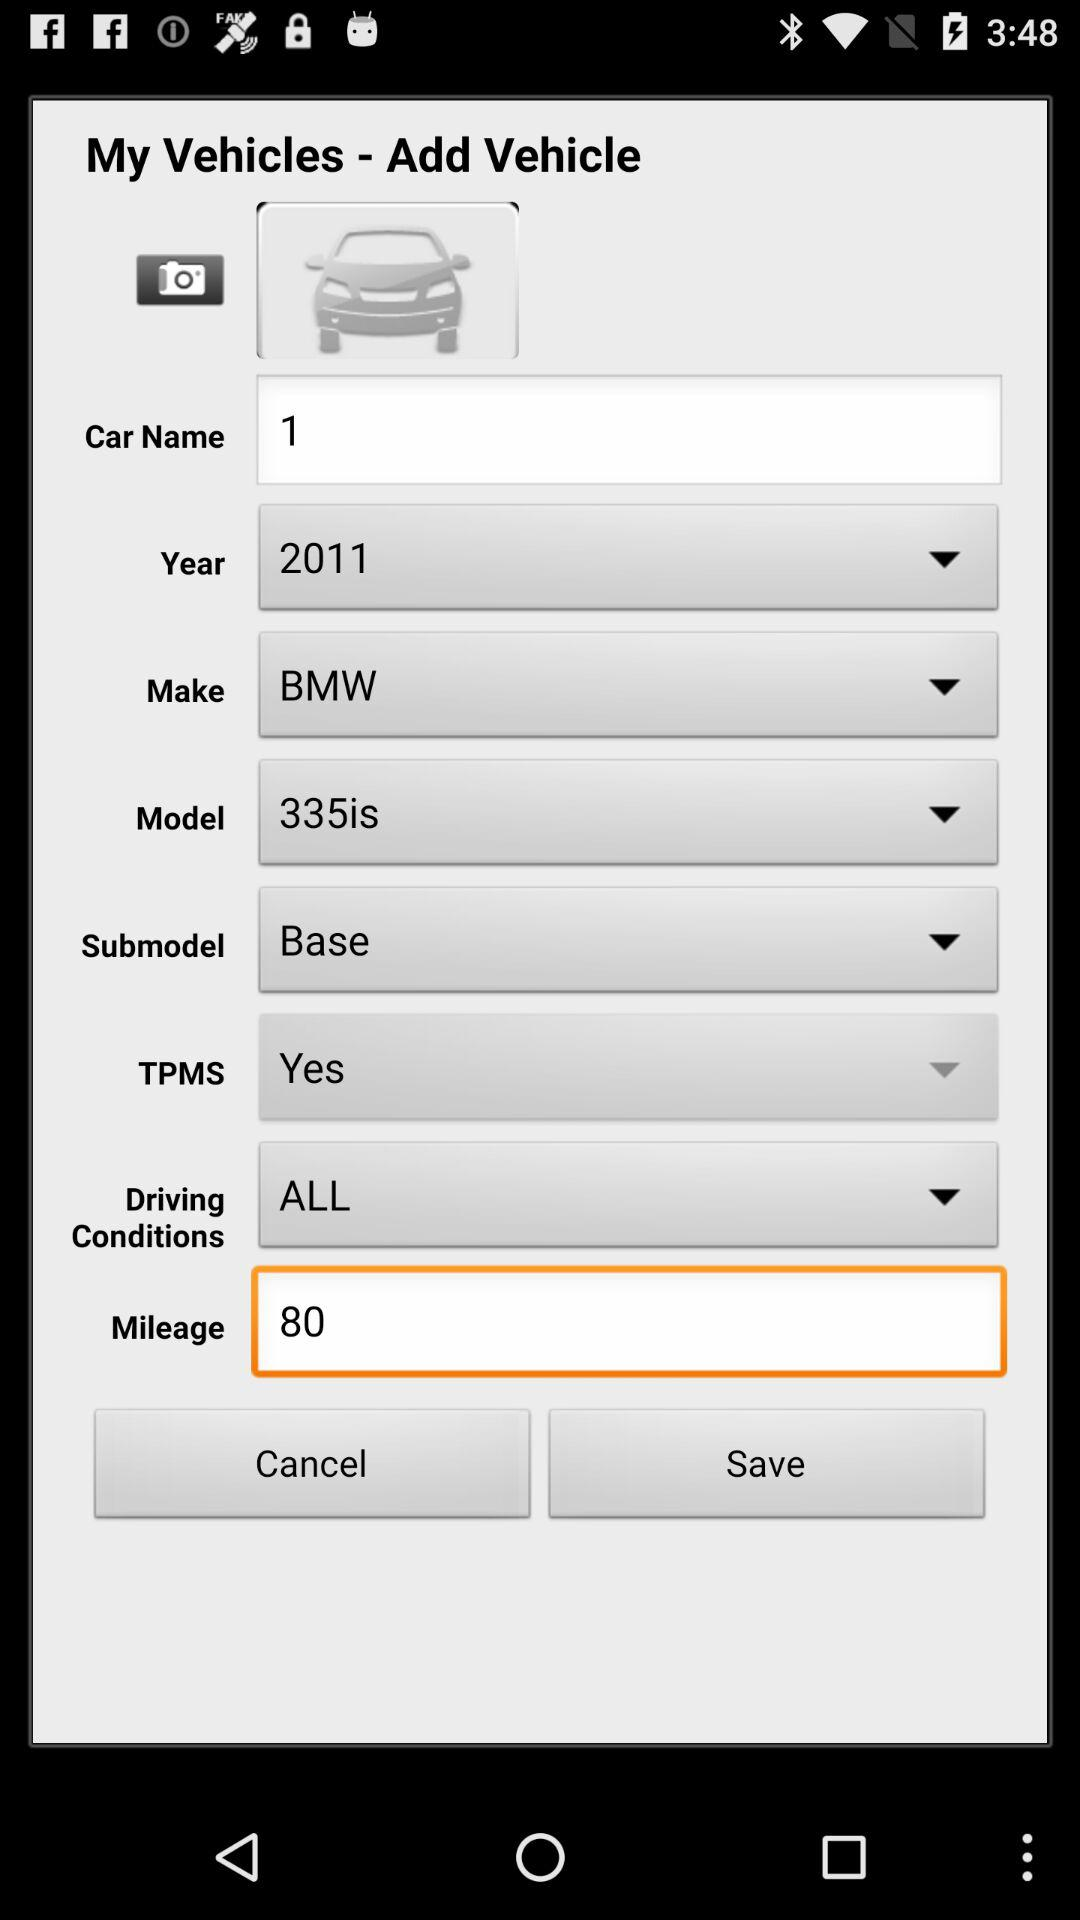Which is the submodel? The submodel is "Base". 